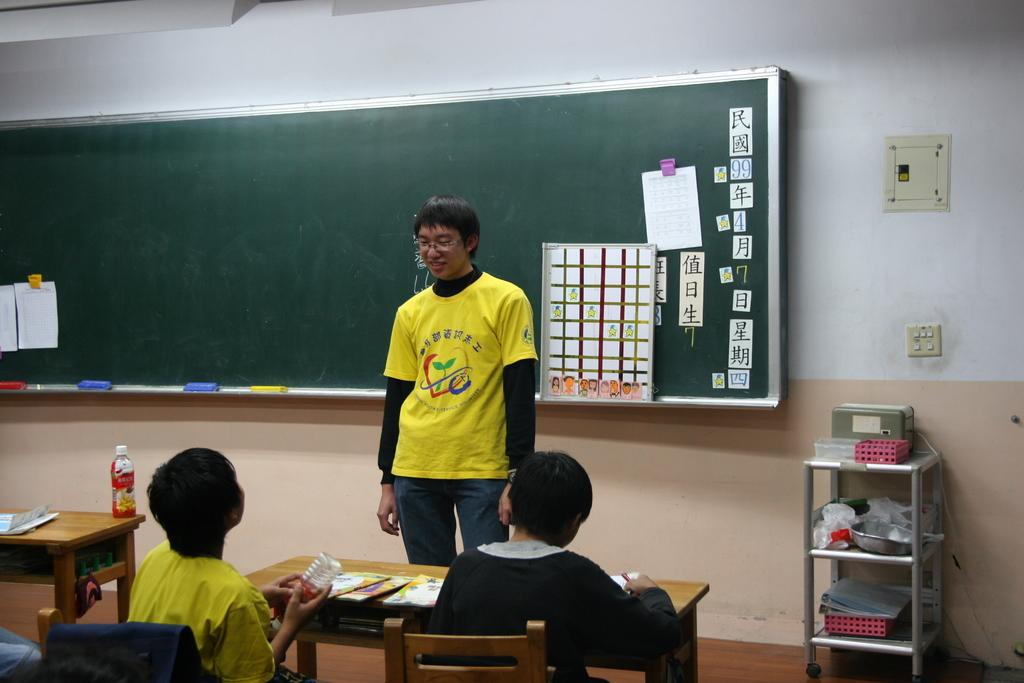What is the primary action of the person in the image? There is a person standing in the image. Are there any other people in the image? Yes, there are people sitting on a bench in front of the standing person. What can be seen behind the standing person? There is a board visible at the back of the standing person. What type of berry is being picked by the women in the image? There are no women or berries present in the image. 